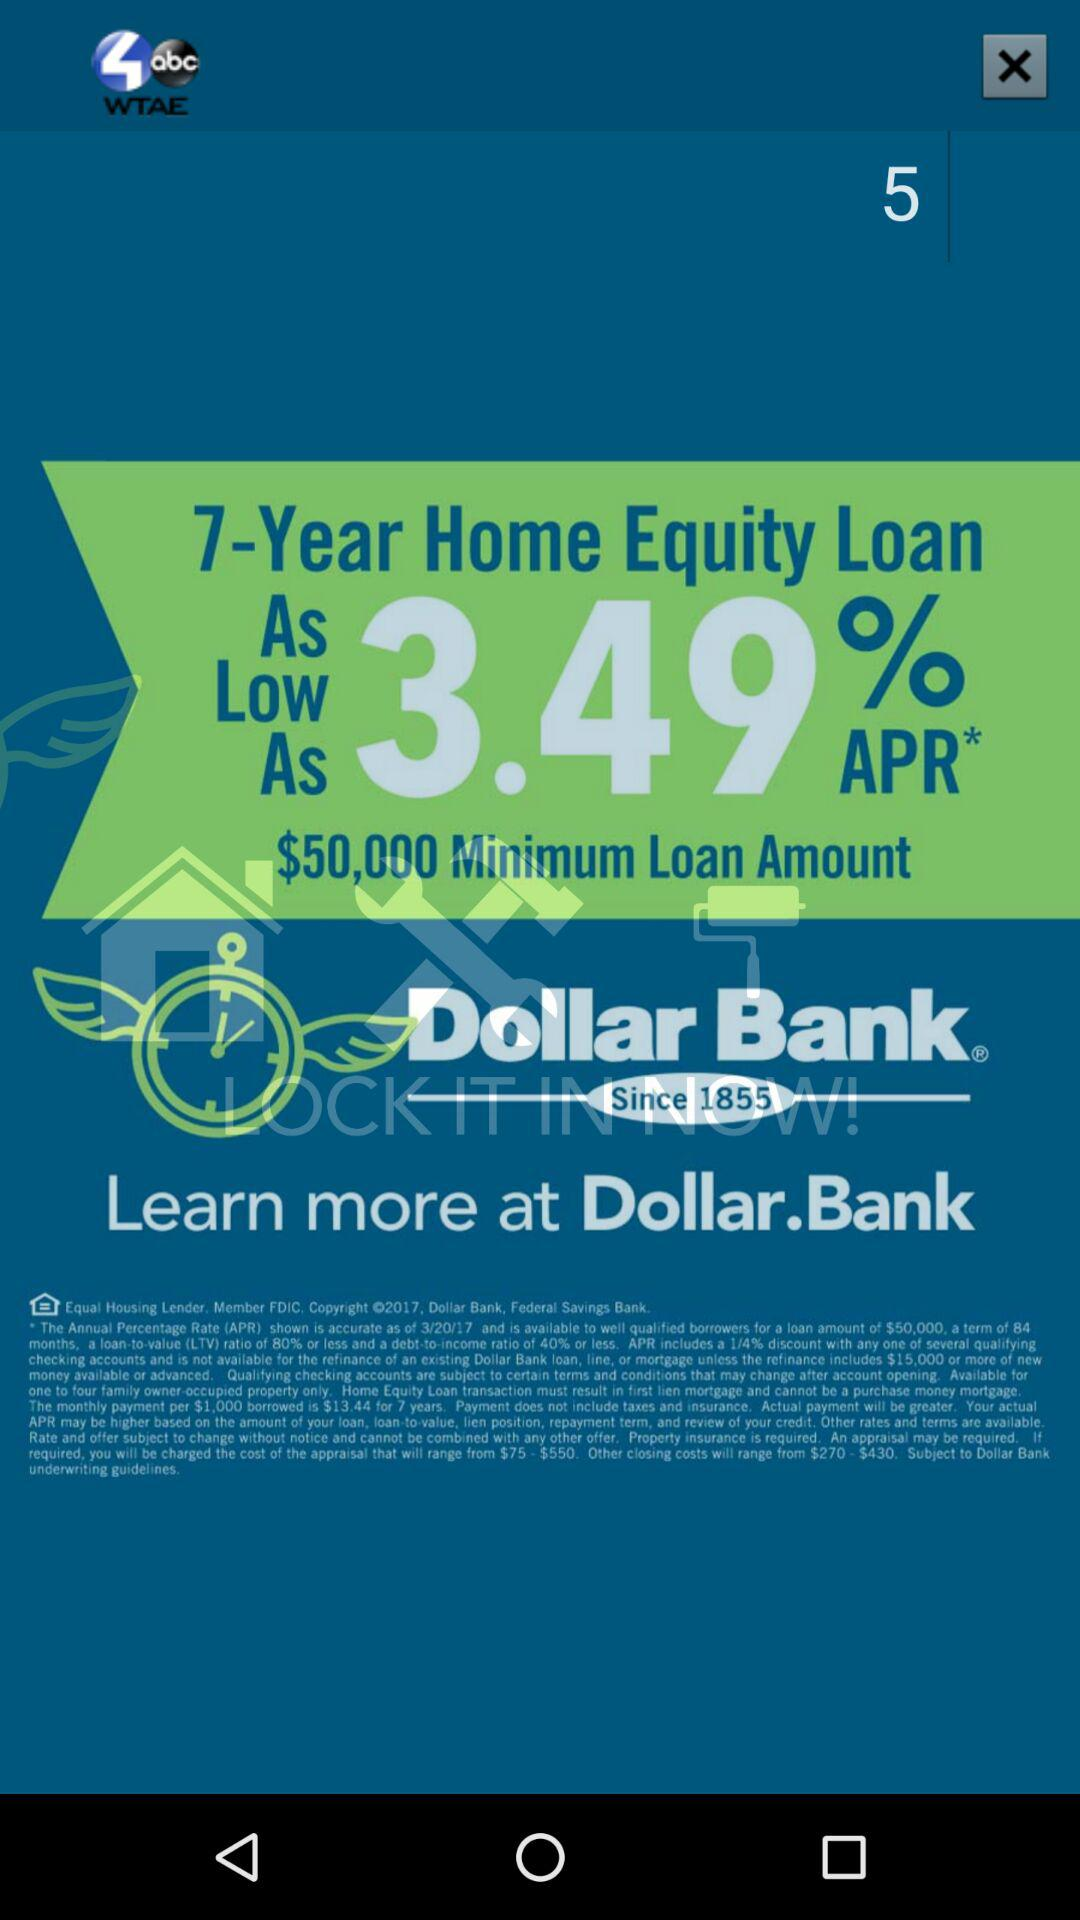What is the minimum loan amount required for this offer?
Answer the question using a single word or phrase. $50,000 